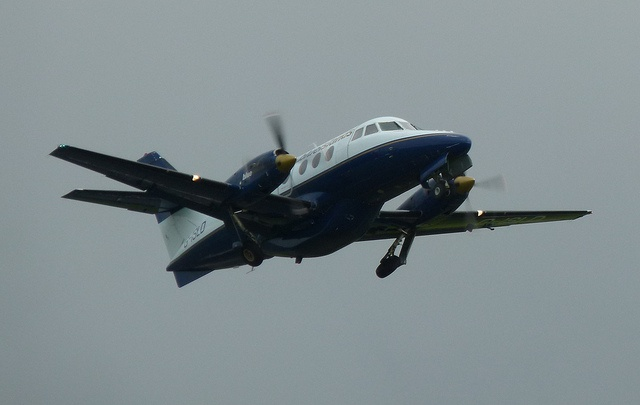Describe the objects in this image and their specific colors. I can see a airplane in darkgray, black, gray, and navy tones in this image. 